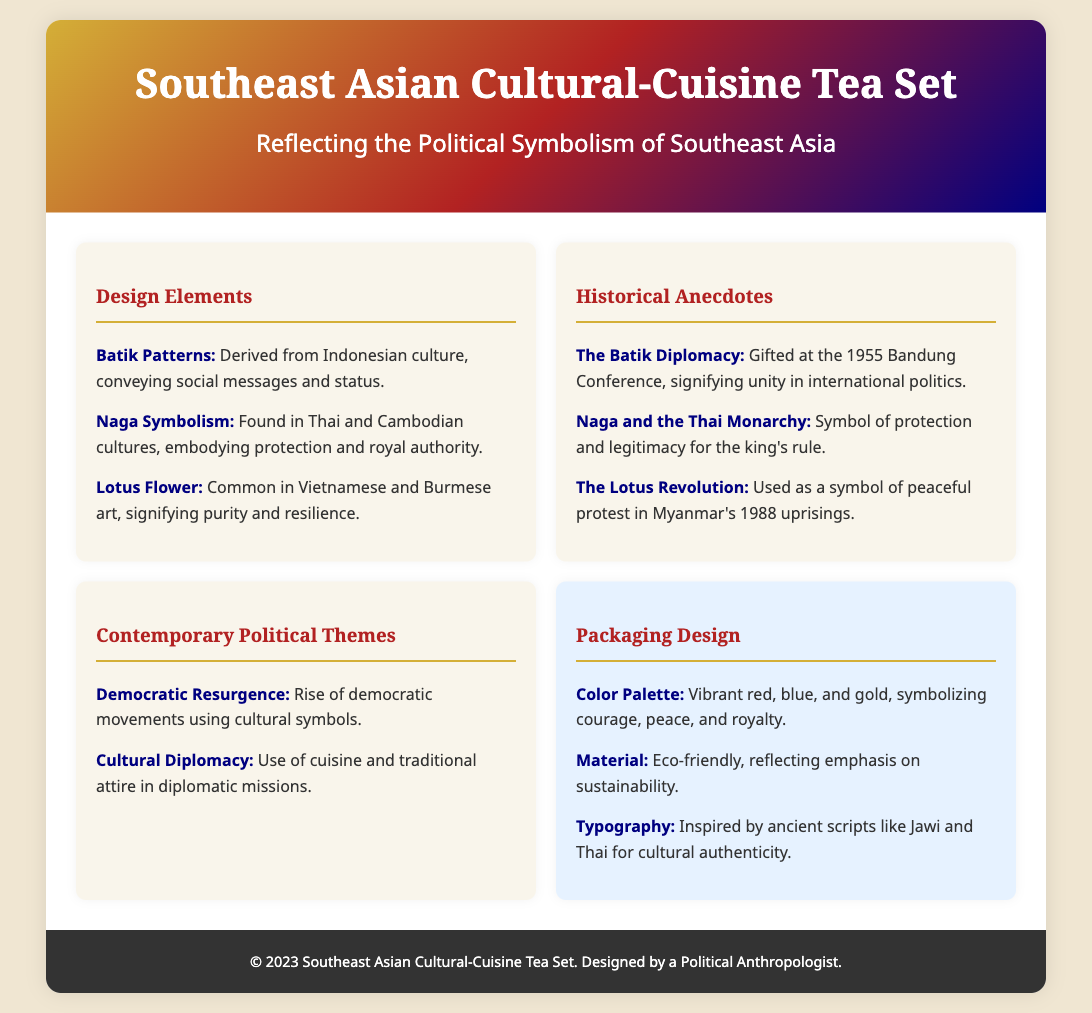What designs are included in the tea set? The document lists specific design elements such as Batik Patterns, Naga Symbolism, and Lotus Flower.
Answer: Batik Patterns, Naga Symbolism, Lotus Flower What historical anecdote is related to the Bandung Conference? The document mentions "The Batik Diplomacy" as a significant historical event in connection to the Bandung Conference.
Answer: The Batik Diplomacy What colors are used in the packaging design? The packaging design emphasizes a specific color palette that includes vibrant red, blue, and gold.
Answer: Red, blue, and gold What contemporary political theme is associated with democratic movements? The document states that there is a rise of democratic movements that use cultural symbols as a theme.
Answer: Democratic Resurgence Which flower symbolizes purity and resilience in the design elements? The Lotus Flower is specifically mentioned as a symbol of purity and resilience in Vietnamese and Burmese art.
Answer: Lotus Flower What material is the tea set packaging made from? The document specifies that the packaging material is eco-friendly, emphasizing sustainability.
Answer: Eco-friendly Who is credited with designing the packaging? The footer credits a specific individual for the design of the tea set packaging.
Answer: A Political Anthropologist What does the Naga symbolize in Thai culture? The document explains that Naga Symbolism embodies protection and royal authority in Thai and Cambodian cultures.
Answer: Protection and royal authority 